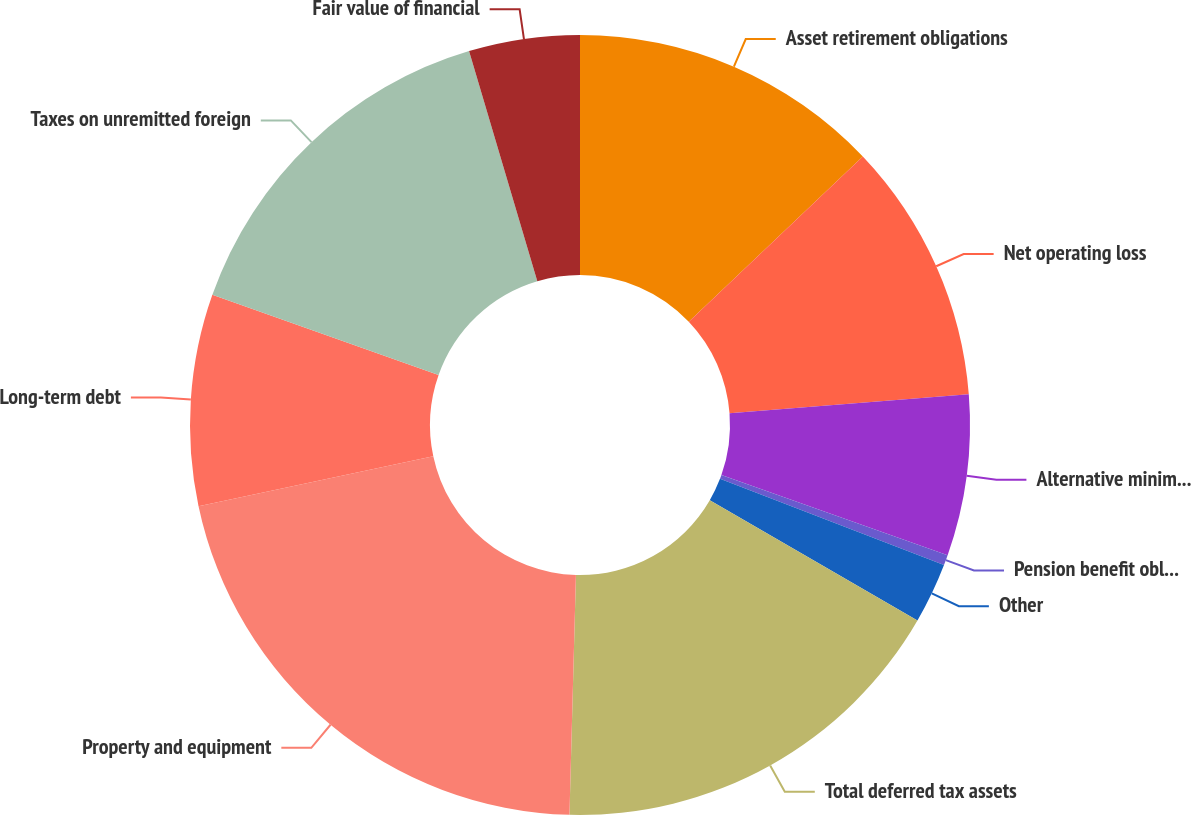<chart> <loc_0><loc_0><loc_500><loc_500><pie_chart><fcel>Asset retirement obligations<fcel>Net operating loss<fcel>Alternative minimum tax<fcel>Pension benefit obligations<fcel>Other<fcel>Total deferred tax assets<fcel>Property and equipment<fcel>Long-term debt<fcel>Taxes on unremitted foreign<fcel>Fair value of financial<nl><fcel>12.91%<fcel>10.83%<fcel>6.67%<fcel>0.43%<fcel>2.51%<fcel>17.07%<fcel>21.23%<fcel>8.75%<fcel>14.99%<fcel>4.59%<nl></chart> 